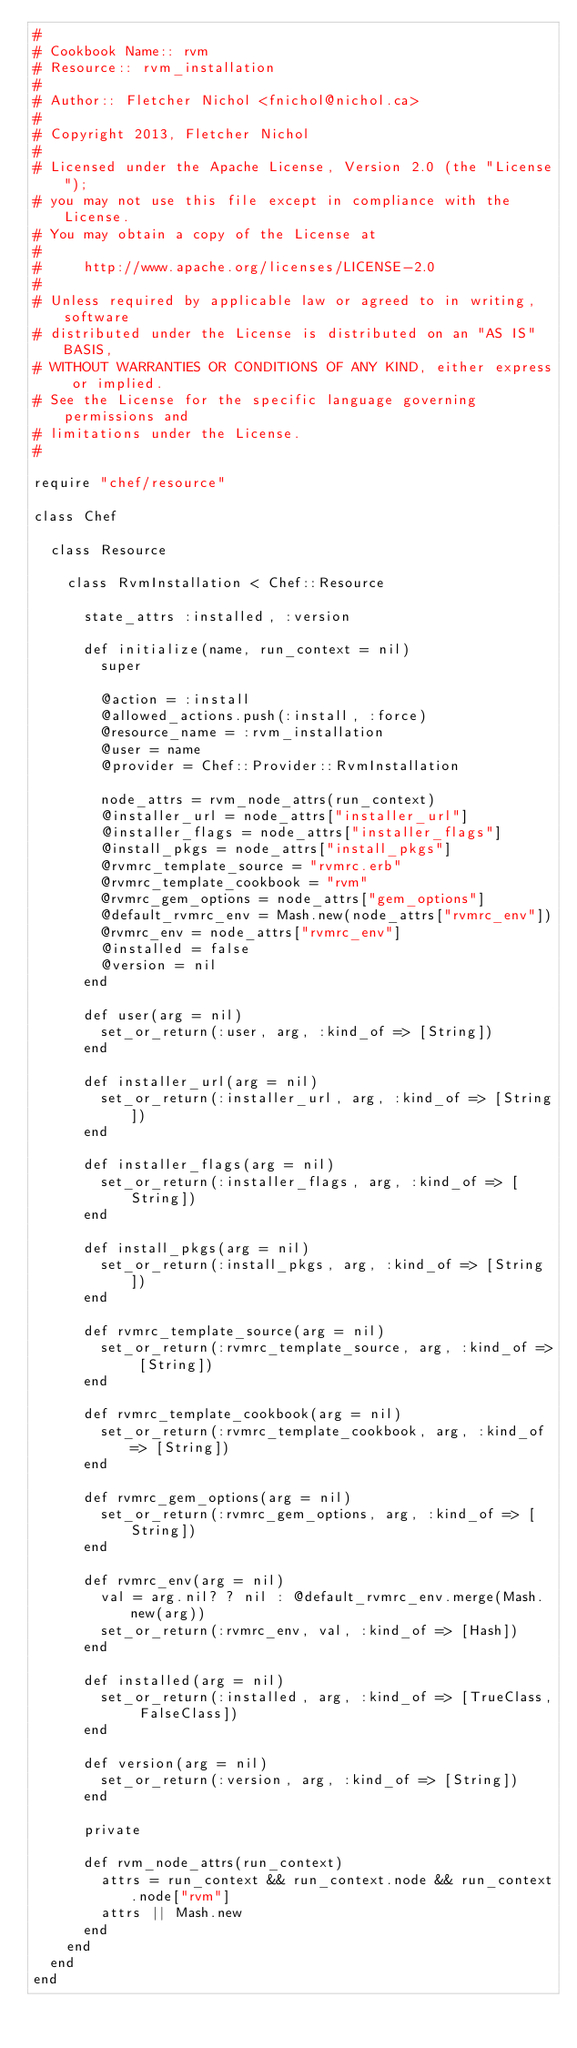Convert code to text. <code><loc_0><loc_0><loc_500><loc_500><_Ruby_>#
# Cookbook Name:: rvm
# Resource:: rvm_installation
#
# Author:: Fletcher Nichol <fnichol@nichol.ca>
#
# Copyright 2013, Fletcher Nichol
#
# Licensed under the Apache License, Version 2.0 (the "License");
# you may not use this file except in compliance with the License.
# You may obtain a copy of the License at
#
#     http://www.apache.org/licenses/LICENSE-2.0
#
# Unless required by applicable law or agreed to in writing, software
# distributed under the License is distributed on an "AS IS" BASIS,
# WITHOUT WARRANTIES OR CONDITIONS OF ANY KIND, either express or implied.
# See the License for the specific language governing permissions and
# limitations under the License.
#

require "chef/resource"

class Chef

  class Resource

    class RvmInstallation < Chef::Resource

      state_attrs :installed, :version

      def initialize(name, run_context = nil)
        super

        @action = :install
        @allowed_actions.push(:install, :force)
        @resource_name = :rvm_installation
        @user = name
        @provider = Chef::Provider::RvmInstallation

        node_attrs = rvm_node_attrs(run_context)
        @installer_url = node_attrs["installer_url"]
        @installer_flags = node_attrs["installer_flags"]
        @install_pkgs = node_attrs["install_pkgs"]
        @rvmrc_template_source = "rvmrc.erb"
        @rvmrc_template_cookbook = "rvm"
        @rvmrc_gem_options = node_attrs["gem_options"]
        @default_rvmrc_env = Mash.new(node_attrs["rvmrc_env"])
        @rvmrc_env = node_attrs["rvmrc_env"]
        @installed = false
        @version = nil
      end

      def user(arg = nil)
        set_or_return(:user, arg, :kind_of => [String])
      end

      def installer_url(arg = nil)
        set_or_return(:installer_url, arg, :kind_of => [String])
      end

      def installer_flags(arg = nil)
        set_or_return(:installer_flags, arg, :kind_of => [String])
      end

      def install_pkgs(arg = nil)
        set_or_return(:install_pkgs, arg, :kind_of => [String])
      end

      def rvmrc_template_source(arg = nil)
        set_or_return(:rvmrc_template_source, arg, :kind_of => [String])
      end

      def rvmrc_template_cookbook(arg = nil)
        set_or_return(:rvmrc_template_cookbook, arg, :kind_of => [String])
      end

      def rvmrc_gem_options(arg = nil)
        set_or_return(:rvmrc_gem_options, arg, :kind_of => [String])
      end

      def rvmrc_env(arg = nil)
        val = arg.nil? ? nil : @default_rvmrc_env.merge(Mash.new(arg))
        set_or_return(:rvmrc_env, val, :kind_of => [Hash])
      end

      def installed(arg = nil)
        set_or_return(:installed, arg, :kind_of => [TrueClass, FalseClass])
      end

      def version(arg = nil)
        set_or_return(:version, arg, :kind_of => [String])
      end

      private

      def rvm_node_attrs(run_context)
        attrs = run_context && run_context.node && run_context.node["rvm"]
        attrs || Mash.new
      end
    end
  end
end
</code> 